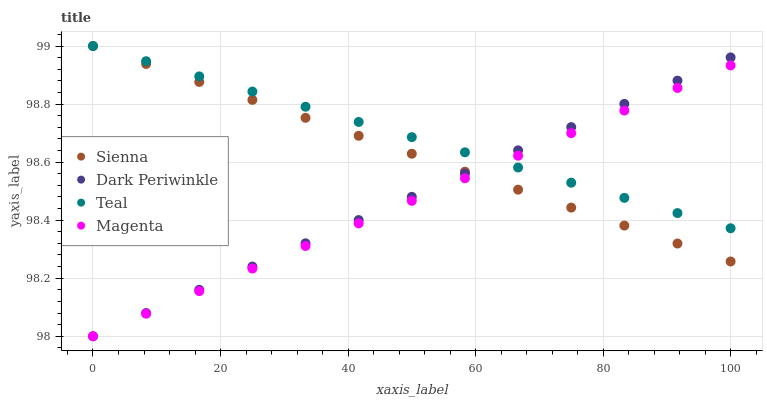Does Magenta have the minimum area under the curve?
Answer yes or no. Yes. Does Teal have the maximum area under the curve?
Answer yes or no. Yes. Does Dark Periwinkle have the minimum area under the curve?
Answer yes or no. No. Does Dark Periwinkle have the maximum area under the curve?
Answer yes or no. No. Is Magenta the smoothest?
Answer yes or no. Yes. Is Teal the roughest?
Answer yes or no. Yes. Is Dark Periwinkle the smoothest?
Answer yes or no. No. Is Dark Periwinkle the roughest?
Answer yes or no. No. Does Magenta have the lowest value?
Answer yes or no. Yes. Does Teal have the lowest value?
Answer yes or no. No. Does Teal have the highest value?
Answer yes or no. Yes. Does Dark Periwinkle have the highest value?
Answer yes or no. No. Does Magenta intersect Sienna?
Answer yes or no. Yes. Is Magenta less than Sienna?
Answer yes or no. No. Is Magenta greater than Sienna?
Answer yes or no. No. 